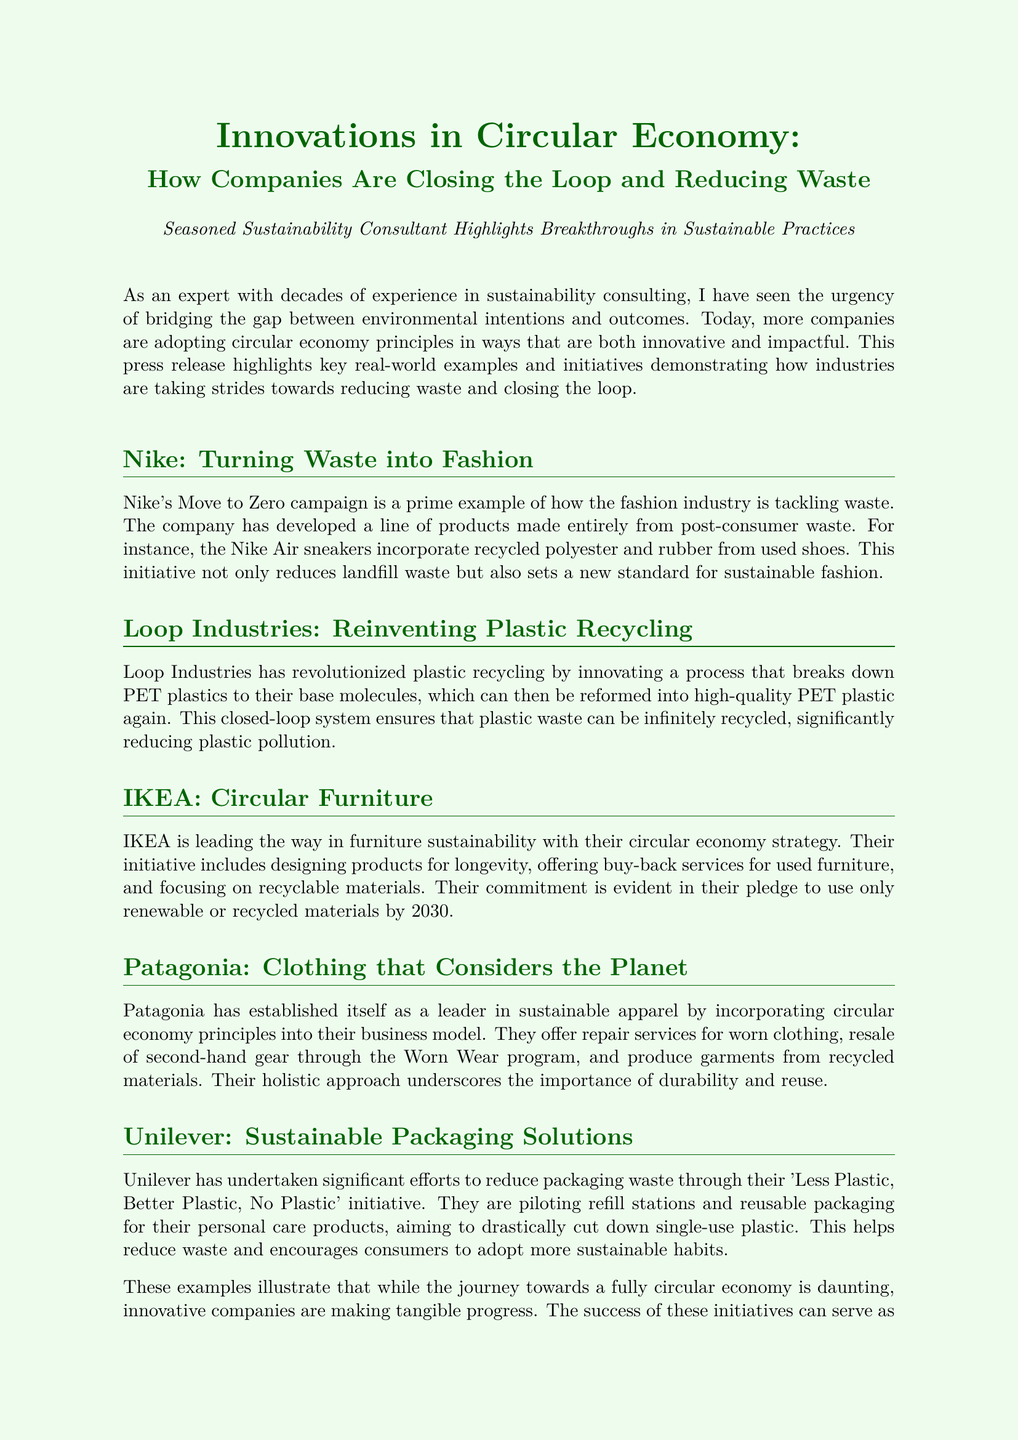What is Nike's sustainability campaign called? The name of Nike's sustainability campaign is mentioned as "Move to Zero."
Answer: Move to Zero What does Loop Industries innovate? The document states that Loop Industries innovates a process that breaks down PET plastics to their base molecules.
Answer: Plastic recycling What is IKEA's pledge for 2030? The document highlights IKEA's commitment to use only renewable or recycled materials by the year 2030.
Answer: Renewable or recycled materials What program does Patagonia offer for second-hand gear? Patagonia offers the "Worn Wear" program for the resale of second-hand gear.
Answer: Worn Wear What initiative has Unilever undertaken to reduce packaging waste? Unilever's initiative is referred to as "Less Plastic, Better Plastic, No Plastic."
Answer: Less Plastic, Better Plastic, No Plastic Which company develops products from post-consumer waste? Nike is the company developing products made entirely from post-consumer waste.
Answer: Nike What is a major focus of IKEA's circular economy strategy? The document states that a major focus of IKEA's strategy is on designing products for longevity.
Answer: Designing products for longevity What does Patagonia emphasize in their business model? Patagonia emphasizes durability and reuse as critical aspects of their business model.
Answer: Durability and reuse What is the purpose of Nike Air sneakers in relation to sustainability? The purpose of Nike Air sneakers is to incorporate recycled polyester and rubber from used shoes.
Answer: Incorporate recycled polyester and rubber 